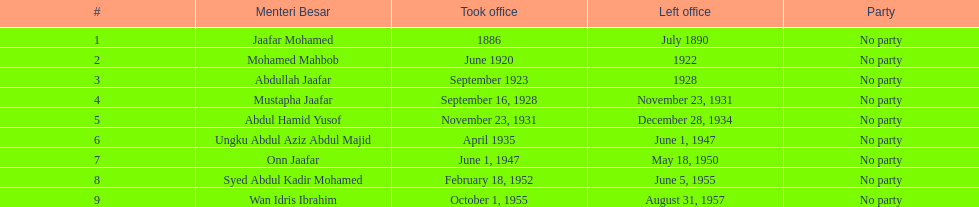Who is cited underneath onn jaafar? Syed Abdul Kadir Mohamed. 